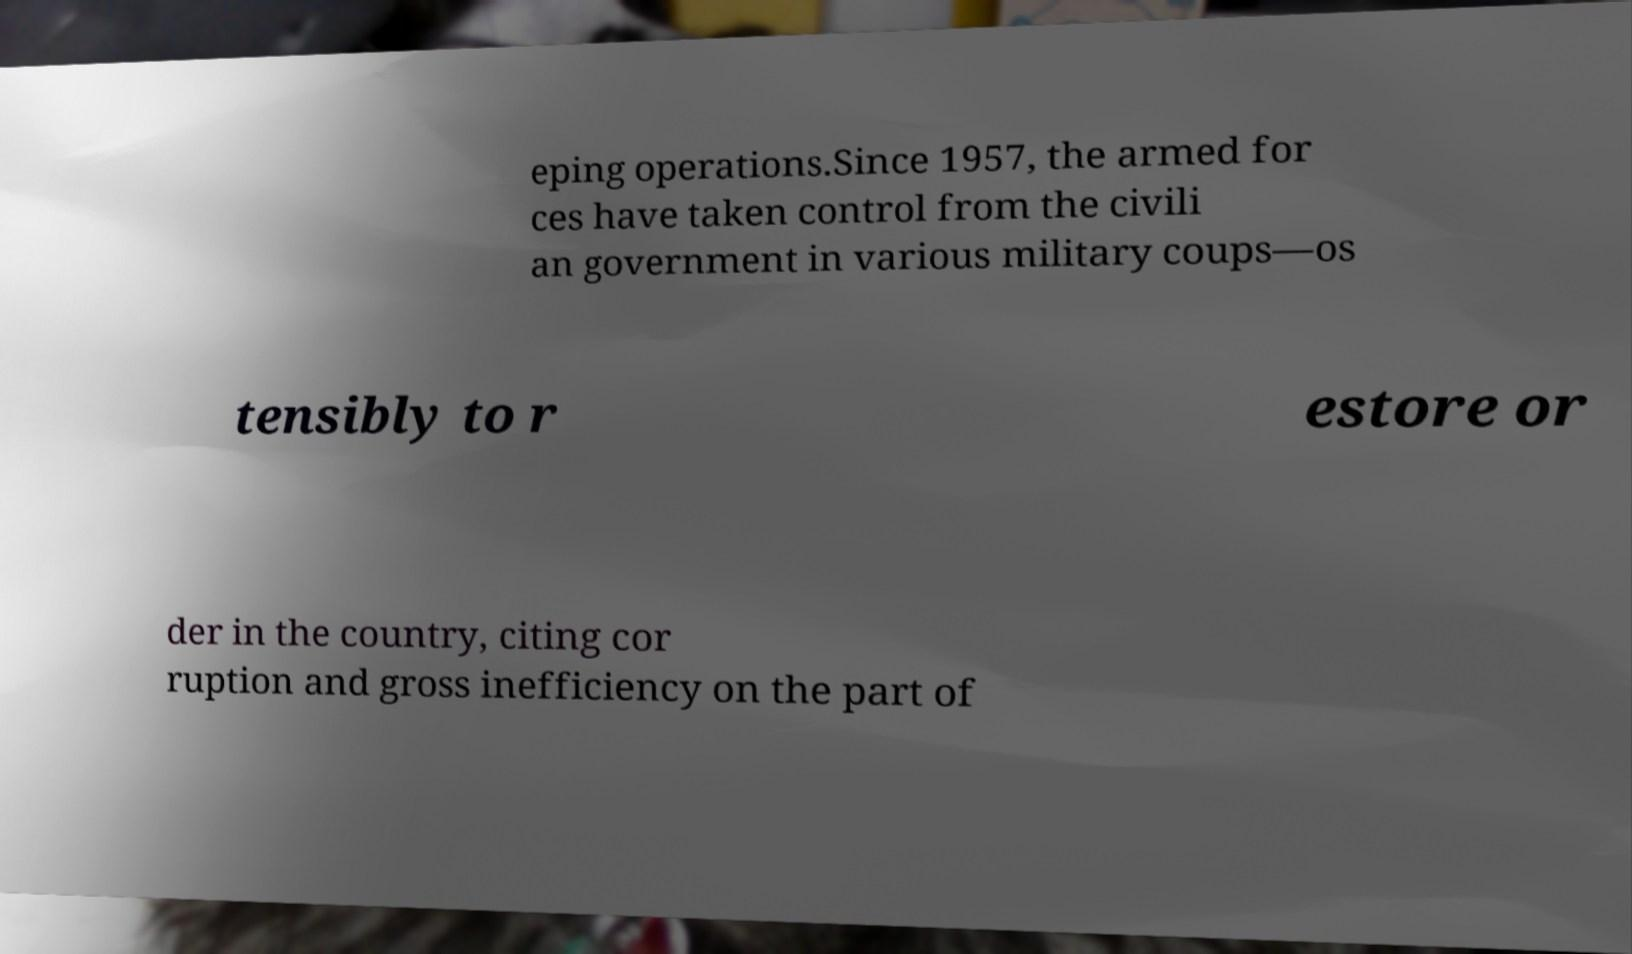What messages or text are displayed in this image? I need them in a readable, typed format. eping operations.Since 1957, the armed for ces have taken control from the civili an government in various military coups—os tensibly to r estore or der in the country, citing cor ruption and gross inefficiency on the part of 